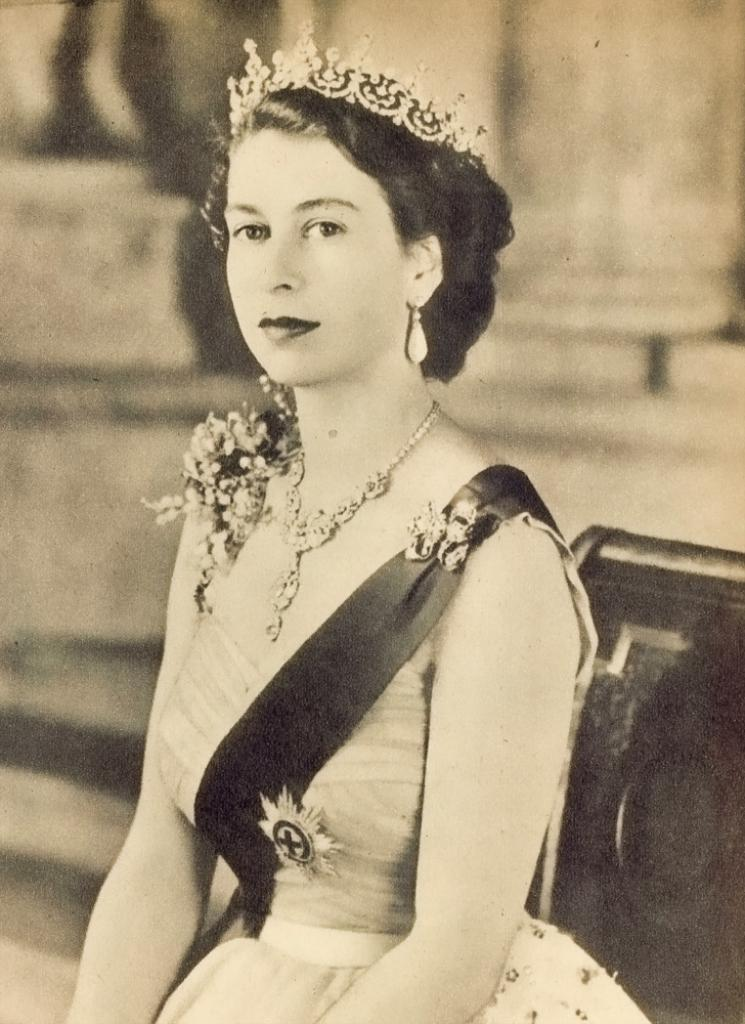What is the color scheme of the image? The image is black and white. Who is present in the image? There is a woman in the image. What is the woman wearing? The woman is wearing a dress. What is the woman's facial expression? The woman is smiling. Can you describe the object behind the woman? There is an object behind the woman, but its details are not clear due to the blurred background. What type of sound can be heard coming from the chair in the image? There is no chair present in the image, and therefore no sound can be heard from it. 